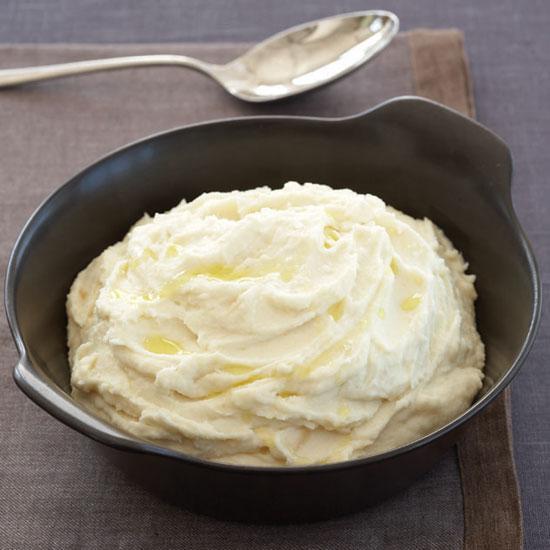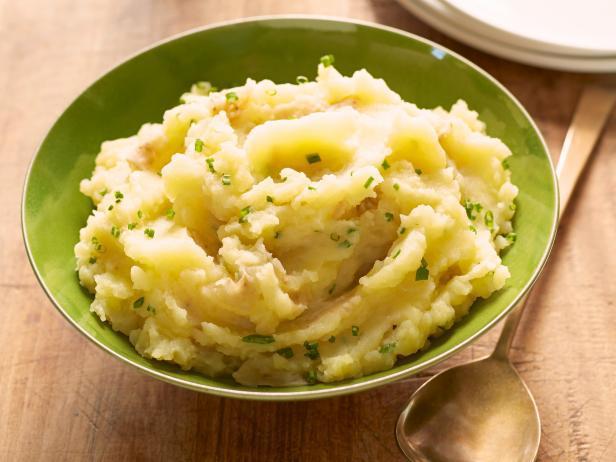The first image is the image on the left, the second image is the image on the right. Examine the images to the left and right. Is the description "At least one image shows mashed potatoes in a round white bowl." accurate? Answer yes or no. No. The first image is the image on the left, the second image is the image on the right. Analyze the images presented: Is the assertion "A white bowl is holding the food in the image on the right." valid? Answer yes or no. No. 